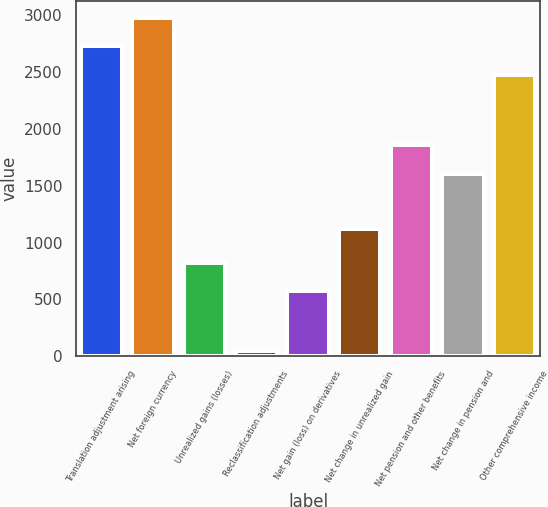Convert chart. <chart><loc_0><loc_0><loc_500><loc_500><bar_chart><fcel>Translation adjustment arising<fcel>Net foreign currency<fcel>Unrealized gains (losses)<fcel>Reclassification adjustments<fcel>Net gain (loss) on derivatives<fcel>Net change in unrealized gain<fcel>Net pension and other benefits<fcel>Net change in pension and<fcel>Other comprehensive income<nl><fcel>2725<fcel>2976<fcel>821<fcel>50<fcel>570<fcel>1122<fcel>1857<fcel>1606<fcel>2474<nl></chart> 